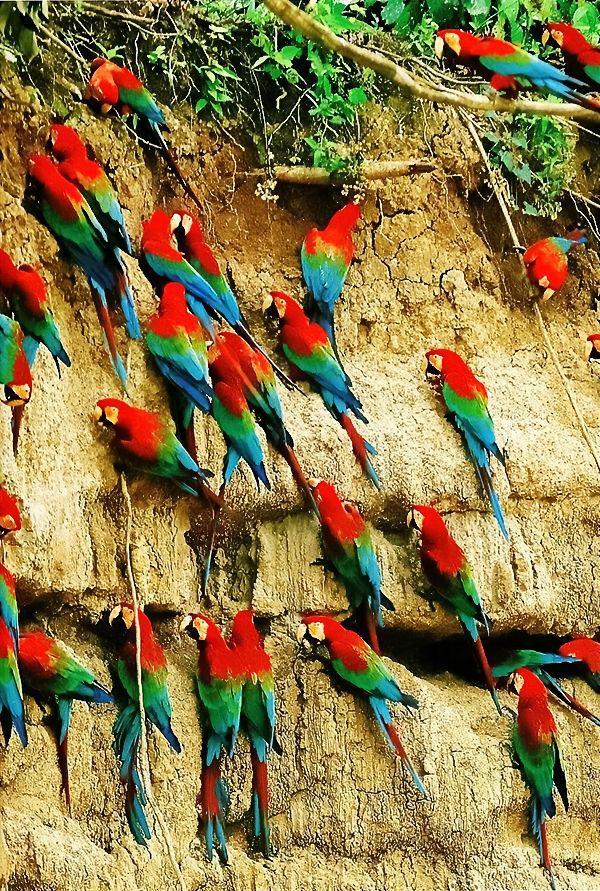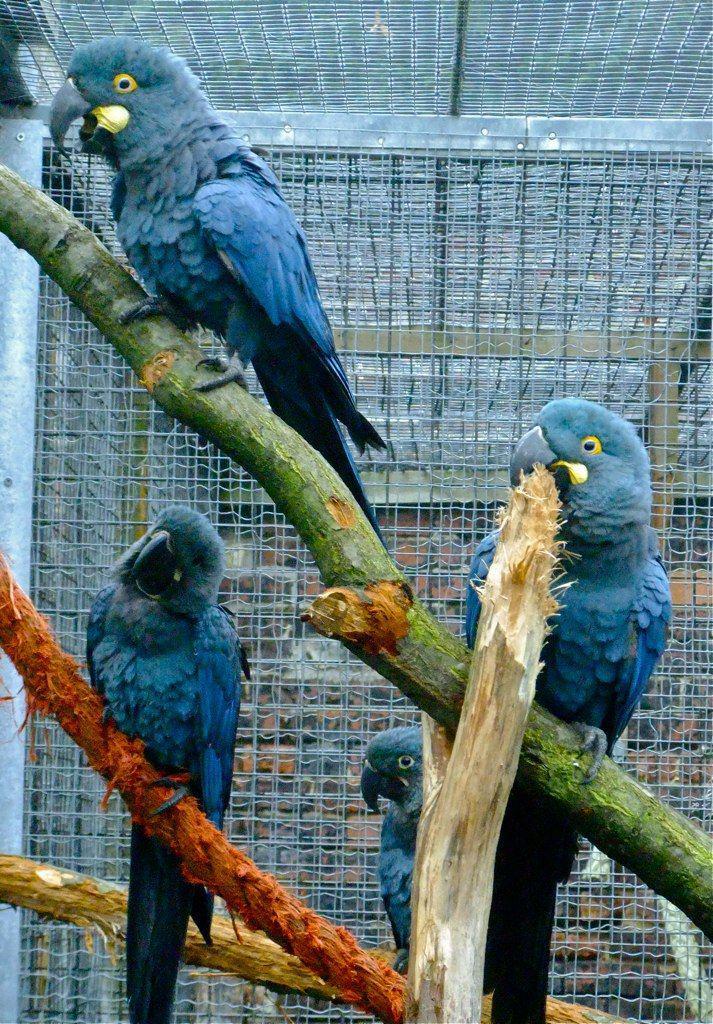The first image is the image on the left, the second image is the image on the right. Assess this claim about the two images: "In one image, parrots are shown with a tall ice cream dessert.". Correct or not? Answer yes or no. No. The first image is the image on the left, the second image is the image on the right. For the images shown, is this caption "there are many birds perched on the side of a cliff in one of the images." true? Answer yes or no. Yes. 